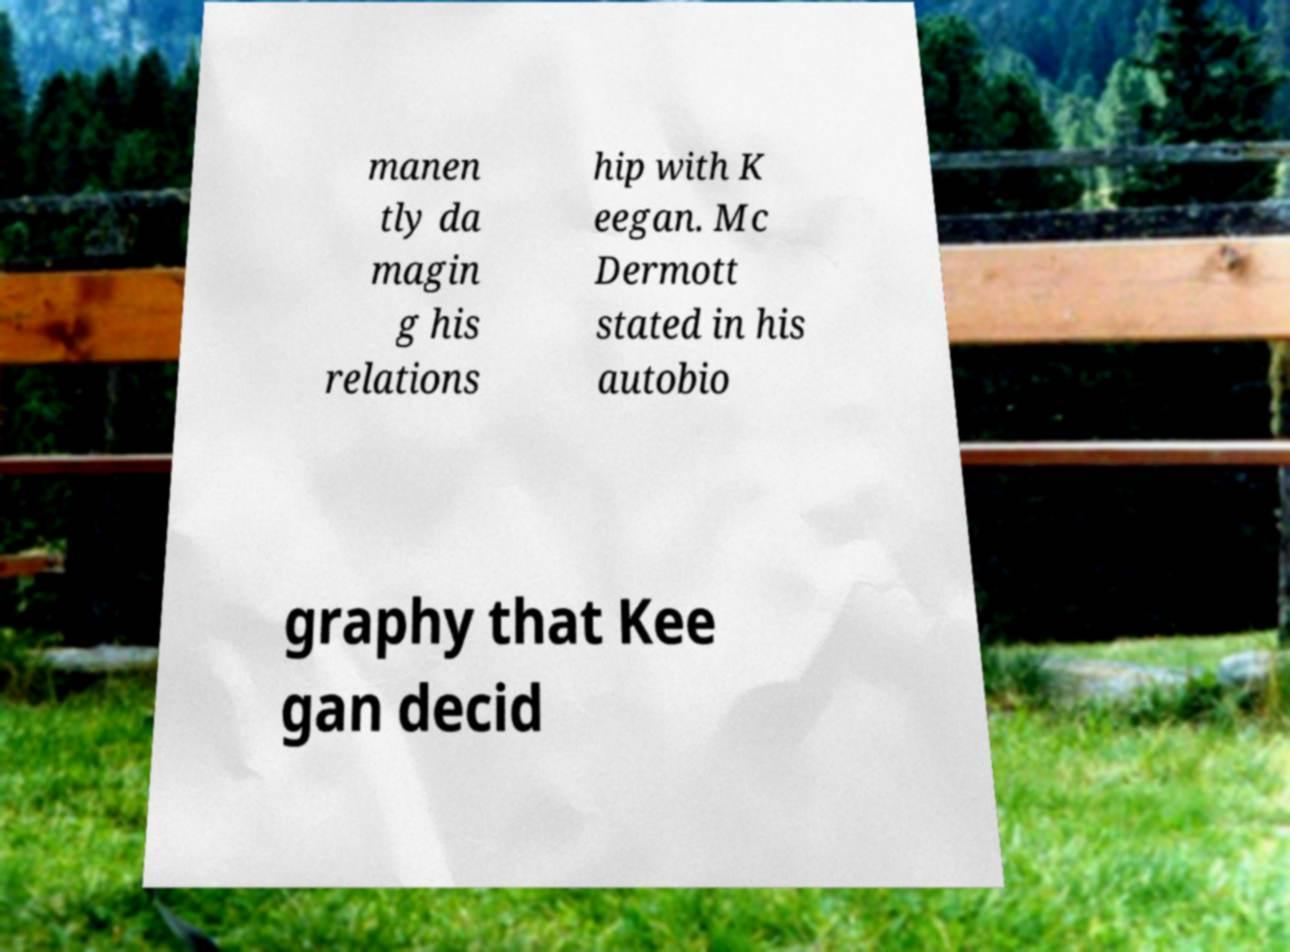What messages or text are displayed in this image? I need them in a readable, typed format. manen tly da magin g his relations hip with K eegan. Mc Dermott stated in his autobio graphy that Kee gan decid 